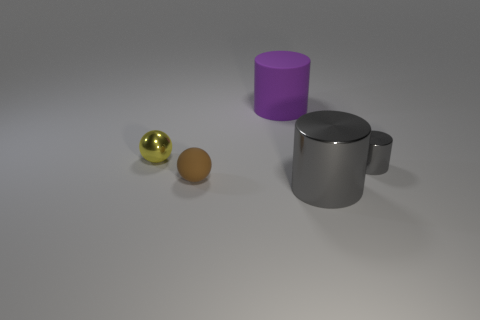Add 2 tiny brown spheres. How many objects exist? 7 Subtract all cylinders. How many objects are left? 2 Add 5 tiny yellow shiny balls. How many tiny yellow shiny balls are left? 6 Add 4 purple cylinders. How many purple cylinders exist? 5 Subtract 1 yellow spheres. How many objects are left? 4 Subtract all big matte cylinders. Subtract all cylinders. How many objects are left? 1 